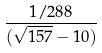Convert formula to latex. <formula><loc_0><loc_0><loc_500><loc_500>\frac { 1 / 2 8 8 } { ( \sqrt { 1 5 7 } - 1 0 ) }</formula> 